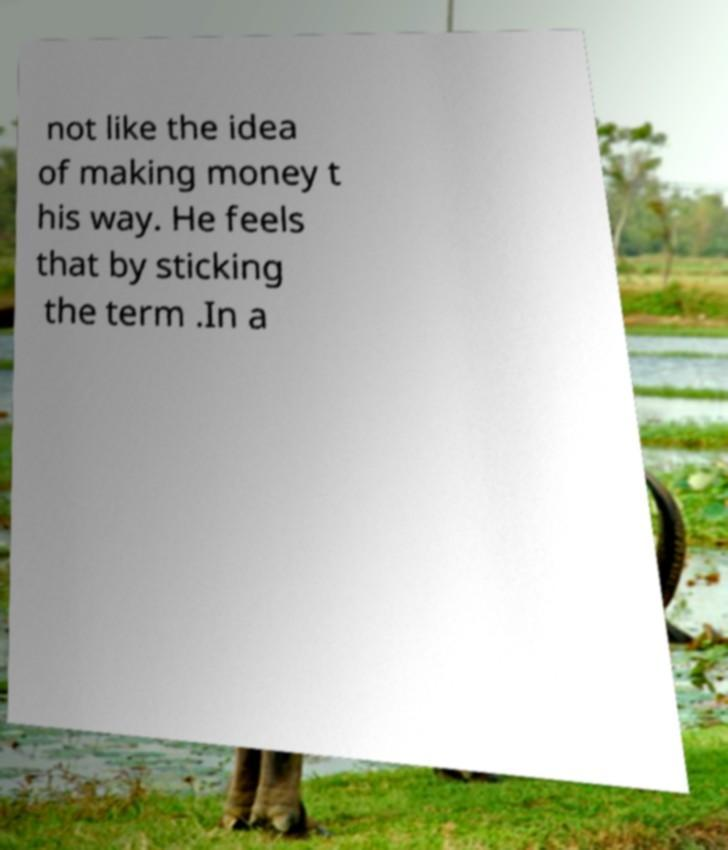What messages or text are displayed in this image? I need them in a readable, typed format. not like the idea of making money t his way. He feels that by sticking the term .In a 